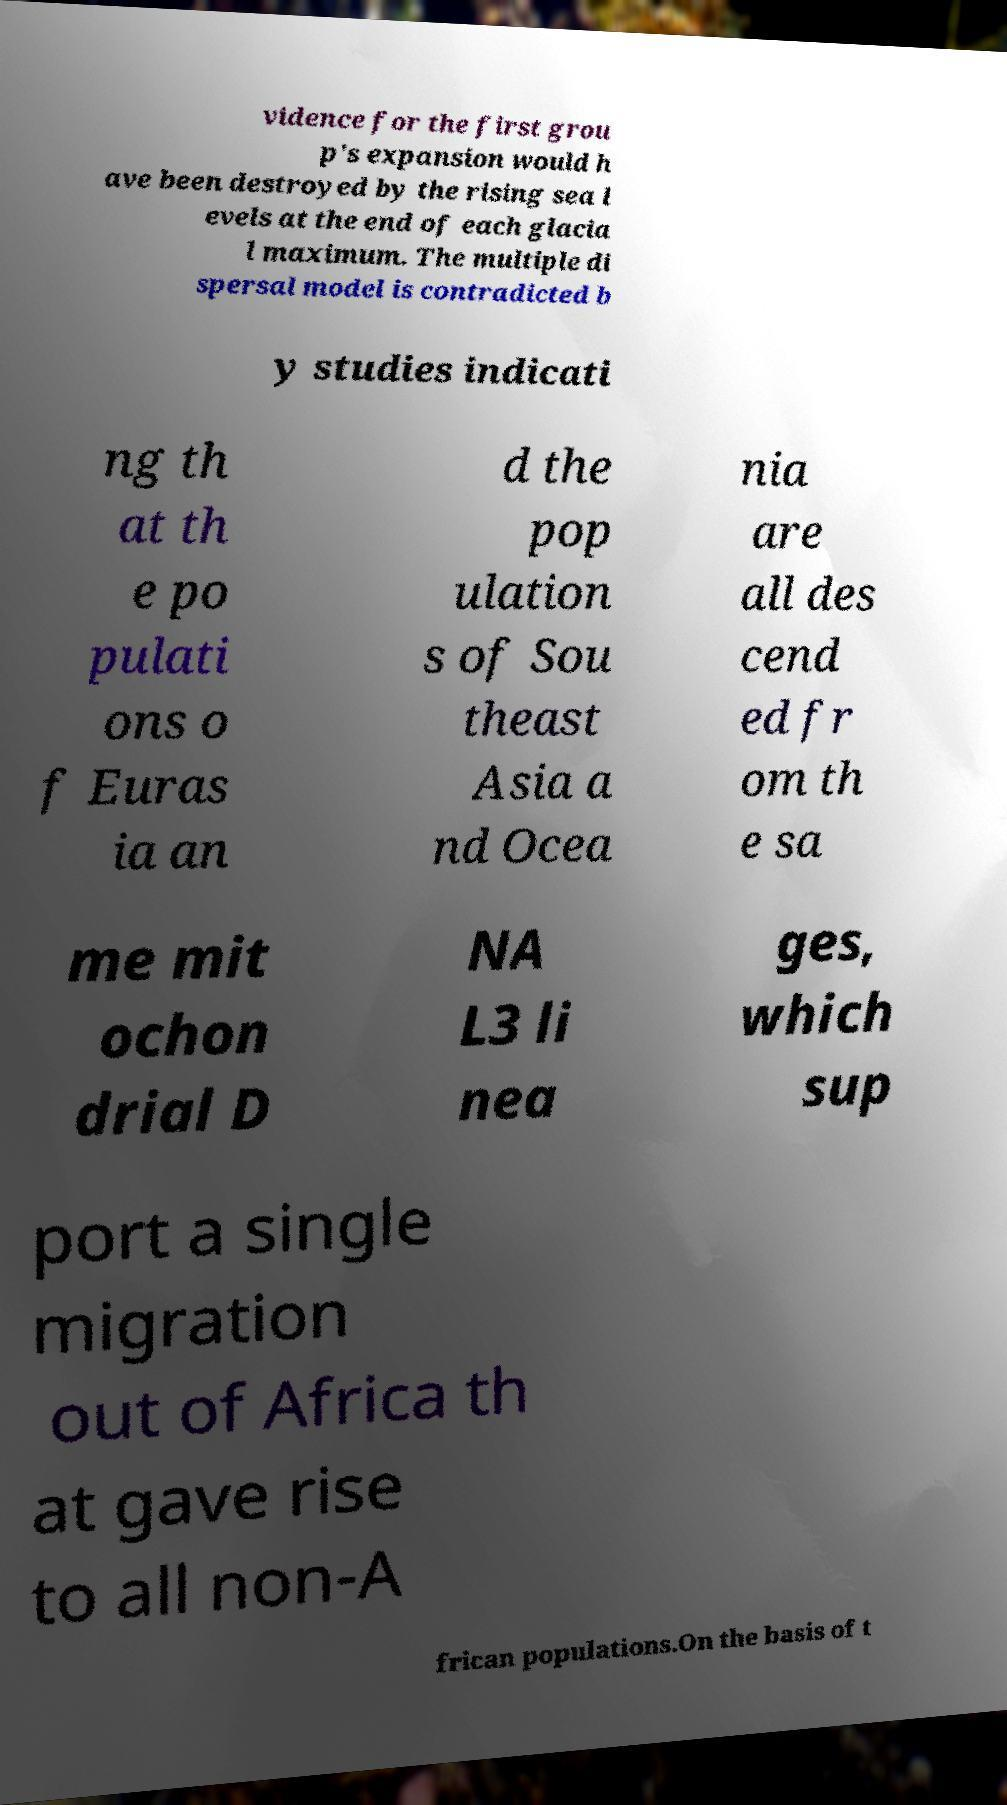Could you extract and type out the text from this image? vidence for the first grou p's expansion would h ave been destroyed by the rising sea l evels at the end of each glacia l maximum. The multiple di spersal model is contradicted b y studies indicati ng th at th e po pulati ons o f Euras ia an d the pop ulation s of Sou theast Asia a nd Ocea nia are all des cend ed fr om th e sa me mit ochon drial D NA L3 li nea ges, which sup port a single migration out of Africa th at gave rise to all non-A frican populations.On the basis of t 